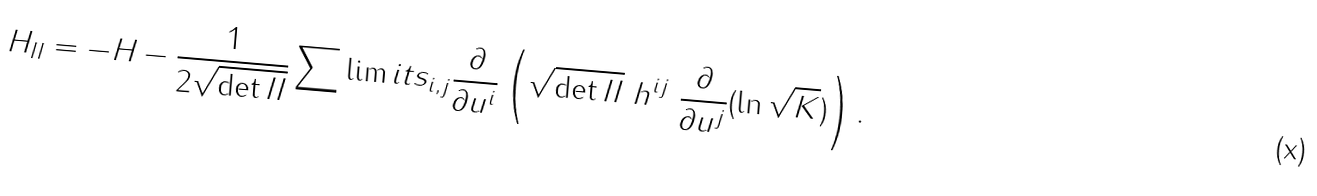<formula> <loc_0><loc_0><loc_500><loc_500>H _ { I I } = - H - \frac { 1 } { 2 \sqrt { \det I I } } \sum \lim i t s _ { i , j } \frac { \partial } { \partial u ^ { i } } \left ( \sqrt { \det I I } \ h ^ { i j } \ \frac { \partial } { \partial u ^ { j } } ( \ln \sqrt { K } ) \right ) .</formula> 